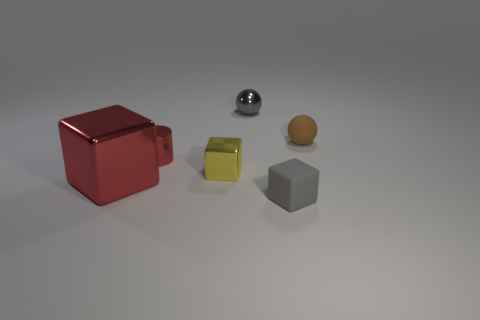Are there any other things that have the same size as the red cube?
Your response must be concise. No. What number of cubes are small gray metal things or small red things?
Give a very brief answer. 0. Are any small red metallic cylinders visible?
Offer a terse response. Yes. What number of other objects are there of the same material as the yellow cube?
Give a very brief answer. 3. What material is the gray cube that is the same size as the brown ball?
Your answer should be very brief. Rubber. Does the matte thing that is on the right side of the tiny gray rubber block have the same shape as the big red metal thing?
Ensure brevity in your answer.  No. Does the large shiny object have the same color as the cylinder?
Your answer should be compact. Yes. How many things are things behind the brown matte sphere or tiny objects?
Your answer should be compact. 5. The gray matte object that is the same size as the metallic cylinder is what shape?
Make the answer very short. Cube. Does the sphere that is left of the brown matte object have the same size as the gray thing that is in front of the brown rubber object?
Make the answer very short. Yes. 